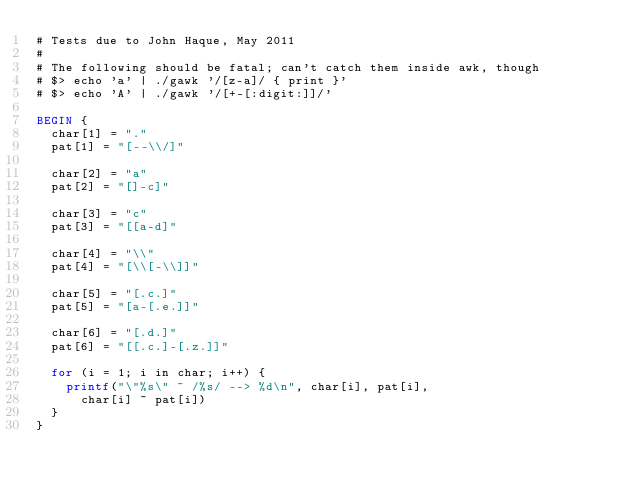<code> <loc_0><loc_0><loc_500><loc_500><_Awk_># Tests due to John Haque, May 2011
#
# The following should be fatal; can't catch them inside awk, though
# $> echo 'a' | ./gawk '/[z-a]/ { print }'
# $> echo 'A' | ./gawk '/[+-[:digit:]]/'

BEGIN {
	char[1] = "."
	pat[1] = "[--\\/]"

	char[2] = "a"
	pat[2] = "[]-c]"

	char[3] = "c"
	pat[3] = "[[a-d]"

	char[4] = "\\"
	pat[4] = "[\\[-\\]]"

	char[5] = "[.c.]"
	pat[5] = "[a-[.e.]]"

	char[6] = "[.d.]"
	pat[6] = "[[.c.]-[.z.]]"

	for (i = 1; i in char; i++) {
		printf("\"%s\" ~ /%s/ --> %d\n", char[i], pat[i],
			char[i] ~ pat[i])
	}
}
</code> 